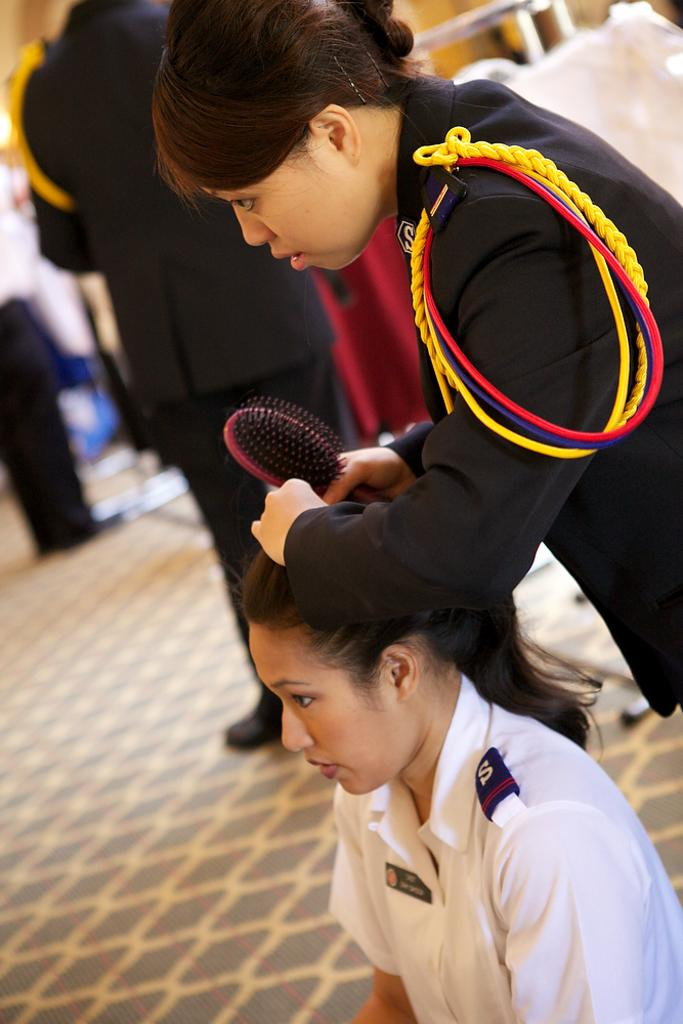How many people are in the image? There are people in the image, but the exact number is not specified. What is one person doing in the image? One person is holding an object in the image. What can be seen in the background of the image? There are stands and a wall in the background of the image. What type of fruit is being shared among the people in the image? There is no fruit present in the image, and the people are not shown sharing anything. 